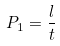<formula> <loc_0><loc_0><loc_500><loc_500>P _ { 1 } = \frac { l } { t }</formula> 